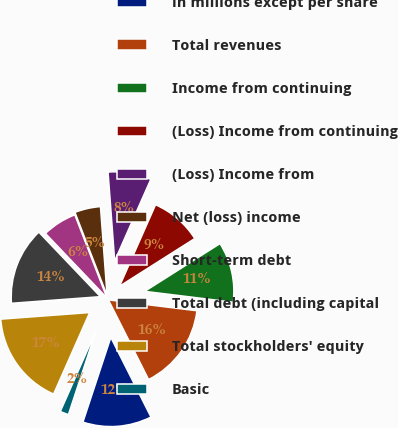<chart> <loc_0><loc_0><loc_500><loc_500><pie_chart><fcel>in millions except per share<fcel>Total revenues<fcel>Income from continuing<fcel>(Loss) Income from continuing<fcel>(Loss) Income from<fcel>Net (loss) income<fcel>Short-term debt<fcel>Total debt (including capital<fcel>Total stockholders' equity<fcel>Basic<nl><fcel>12.5%<fcel>15.62%<fcel>10.94%<fcel>9.38%<fcel>7.81%<fcel>4.69%<fcel>6.25%<fcel>14.06%<fcel>17.19%<fcel>1.56%<nl></chart> 